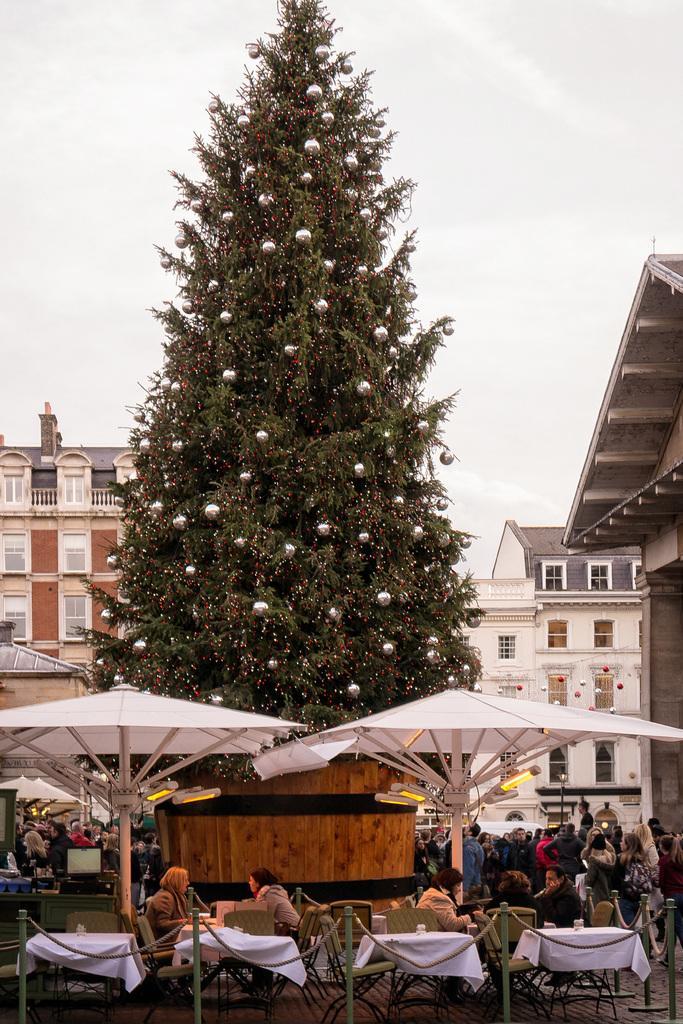In one or two sentences, can you explain what this image depicts? There is a big Christmas tree. In the bottom there are some tables. Some people are sitting on the chair. On their top there is a tent. On the right bottom there are some peoples standing. In the background there are some buildings, roof and on top sky. 